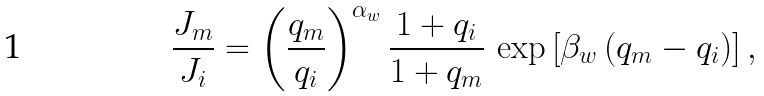<formula> <loc_0><loc_0><loc_500><loc_500>\frac { J _ { m } } { J _ { i } } = \left ( \frac { q _ { m } } { q _ { i } } \right ) ^ { \alpha _ { w } } \frac { 1 + q _ { i } } { 1 + q _ { m } } \, \exp \left [ \beta _ { w } \left ( q _ { m } - q _ { i } \right ) \right ] ,</formula> 